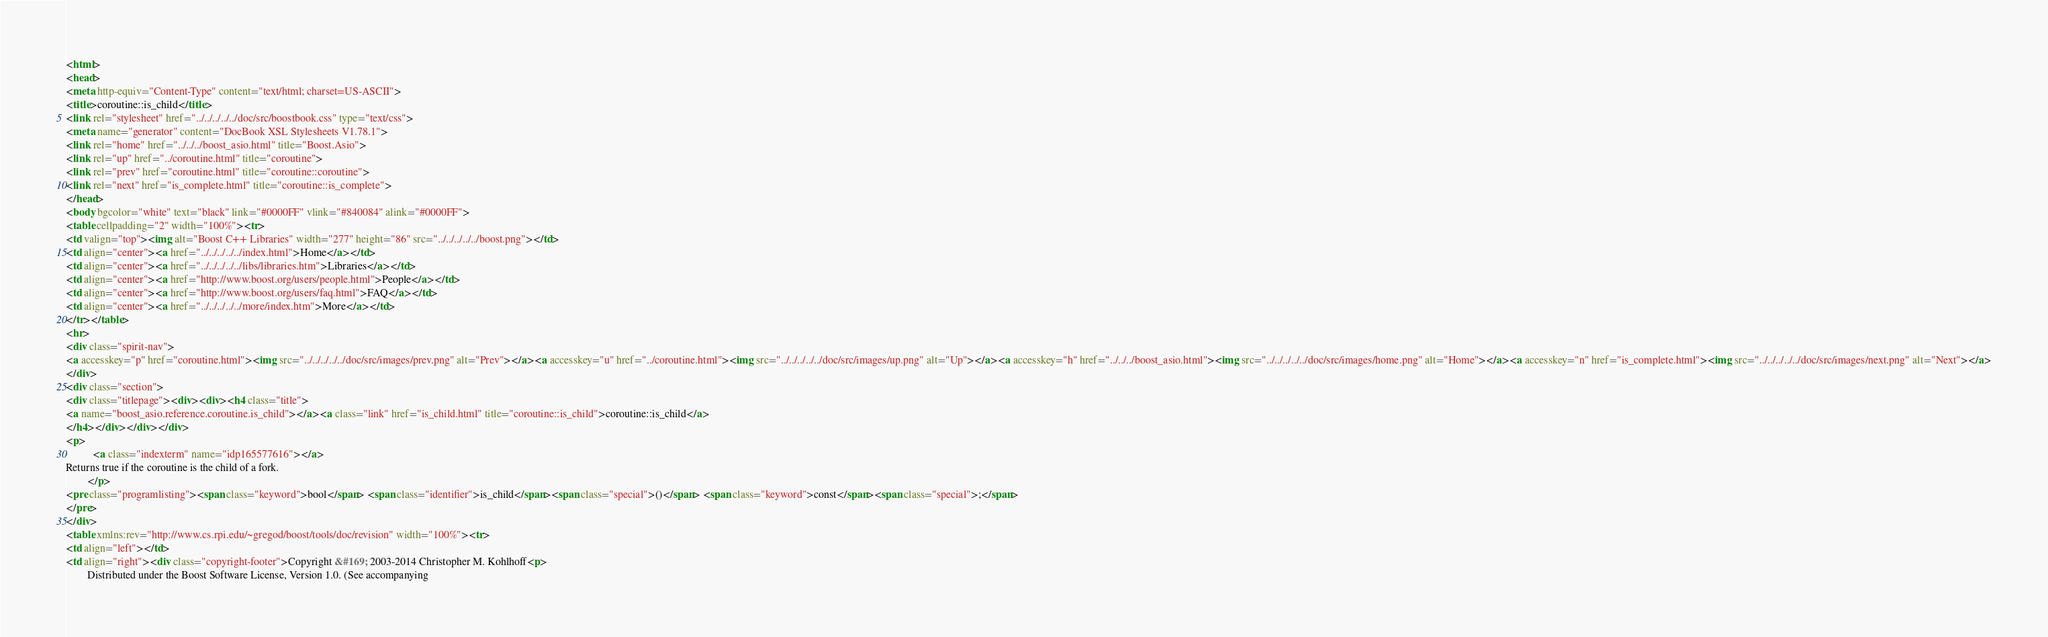Convert code to text. <code><loc_0><loc_0><loc_500><loc_500><_HTML_><html>
<head>
<meta http-equiv="Content-Type" content="text/html; charset=US-ASCII">
<title>coroutine::is_child</title>
<link rel="stylesheet" href="../../../../../doc/src/boostbook.css" type="text/css">
<meta name="generator" content="DocBook XSL Stylesheets V1.78.1">
<link rel="home" href="../../../boost_asio.html" title="Boost.Asio">
<link rel="up" href="../coroutine.html" title="coroutine">
<link rel="prev" href="coroutine.html" title="coroutine::coroutine">
<link rel="next" href="is_complete.html" title="coroutine::is_complete">
</head>
<body bgcolor="white" text="black" link="#0000FF" vlink="#840084" alink="#0000FF">
<table cellpadding="2" width="100%"><tr>
<td valign="top"><img alt="Boost C++ Libraries" width="277" height="86" src="../../../../../boost.png"></td>
<td align="center"><a href="../../../../../index.html">Home</a></td>
<td align="center"><a href="../../../../../libs/libraries.htm">Libraries</a></td>
<td align="center"><a href="http://www.boost.org/users/people.html">People</a></td>
<td align="center"><a href="http://www.boost.org/users/faq.html">FAQ</a></td>
<td align="center"><a href="../../../../../more/index.htm">More</a></td>
</tr></table>
<hr>
<div class="spirit-nav">
<a accesskey="p" href="coroutine.html"><img src="../../../../../doc/src/images/prev.png" alt="Prev"></a><a accesskey="u" href="../coroutine.html"><img src="../../../../../doc/src/images/up.png" alt="Up"></a><a accesskey="h" href="../../../boost_asio.html"><img src="../../../../../doc/src/images/home.png" alt="Home"></a><a accesskey="n" href="is_complete.html"><img src="../../../../../doc/src/images/next.png" alt="Next"></a>
</div>
<div class="section">
<div class="titlepage"><div><div><h4 class="title">
<a name="boost_asio.reference.coroutine.is_child"></a><a class="link" href="is_child.html" title="coroutine::is_child">coroutine::is_child</a>
</h4></div></div></div>
<p>
          <a class="indexterm" name="idp165577616"></a> 
Returns true if the coroutine is the child of a fork.
        </p>
<pre class="programlisting"><span class="keyword">bool</span> <span class="identifier">is_child</span><span class="special">()</span> <span class="keyword">const</span><span class="special">;</span>
</pre>
</div>
<table xmlns:rev="http://www.cs.rpi.edu/~gregod/boost/tools/doc/revision" width="100%"><tr>
<td align="left"></td>
<td align="right"><div class="copyright-footer">Copyright &#169; 2003-2014 Christopher M. Kohlhoff<p>
        Distributed under the Boost Software License, Version 1.0. (See accompanying</code> 